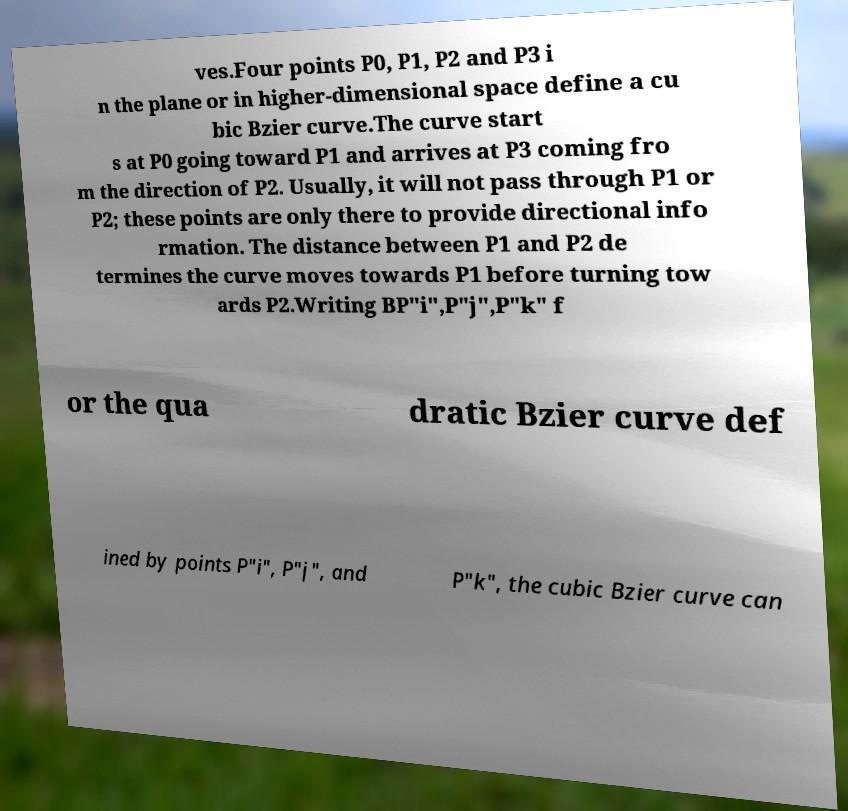What messages or text are displayed in this image? I need them in a readable, typed format. ves.Four points P0, P1, P2 and P3 i n the plane or in higher-dimensional space define a cu bic Bzier curve.The curve start s at P0 going toward P1 and arrives at P3 coming fro m the direction of P2. Usually, it will not pass through P1 or P2; these points are only there to provide directional info rmation. The distance between P1 and P2 de termines the curve moves towards P1 before turning tow ards P2.Writing BP"i",P"j",P"k" f or the qua dratic Bzier curve def ined by points P"i", P"j", and P"k", the cubic Bzier curve can 